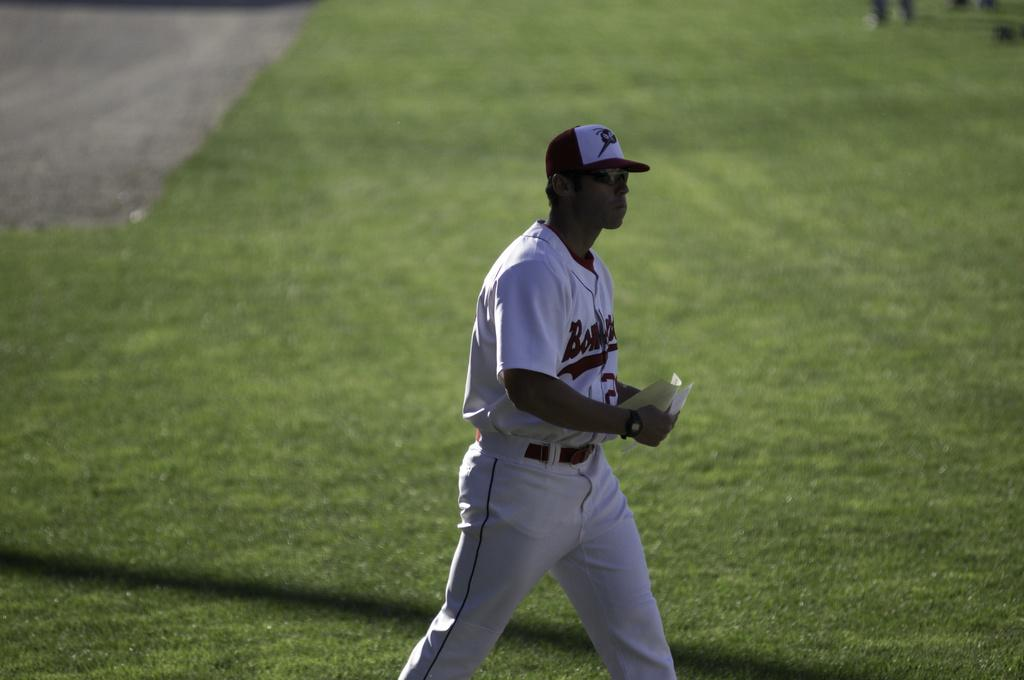<image>
Offer a succinct explanation of the picture presented. A baseball player wears a red and white uniform for the Bombers. 